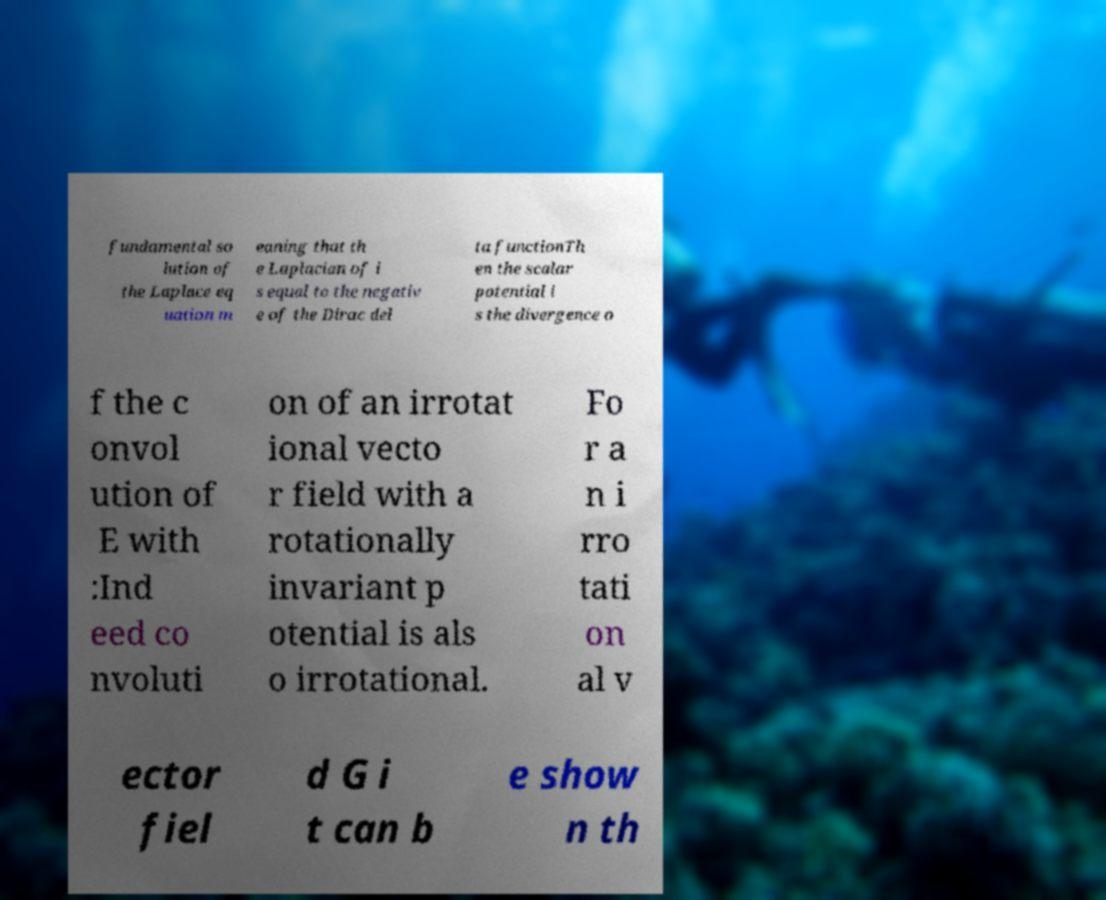Can you accurately transcribe the text from the provided image for me? fundamental so lution of the Laplace eq uation m eaning that th e Laplacian of i s equal to the negativ e of the Dirac del ta functionTh en the scalar potential i s the divergence o f the c onvol ution of E with :Ind eed co nvoluti on of an irrotat ional vecto r field with a rotationally invariant p otential is als o irrotational. Fo r a n i rro tati on al v ector fiel d G i t can b e show n th 